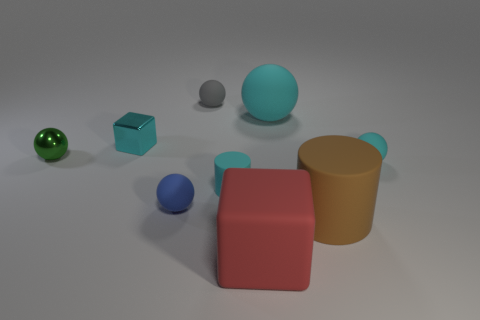What can you infer about the size of the objects? The objects vary in size; the red block and yellow cup are the largest items, while the spheres and the metallic blue block are smaller in comparison. 